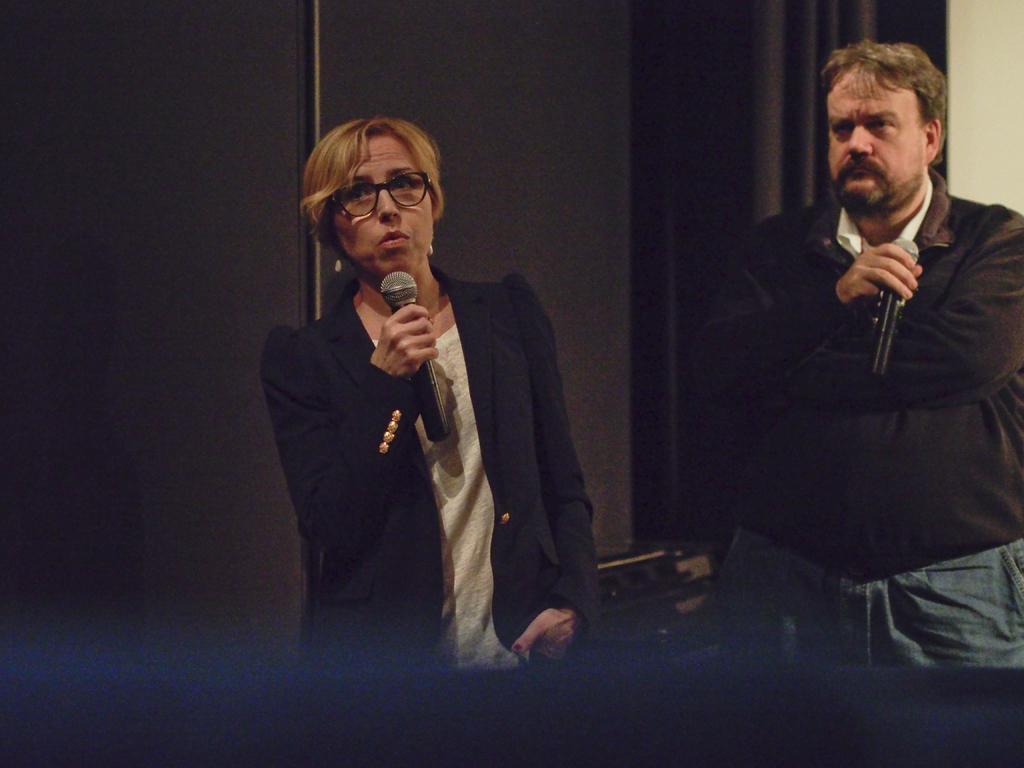In one or two sentences, can you explain what this image depicts? 2 people are standing and holding microphones in their hands. the person at the left is wearing a black blazer, the person at the right is wearing a black shirt. behind them there is a black curtain. 